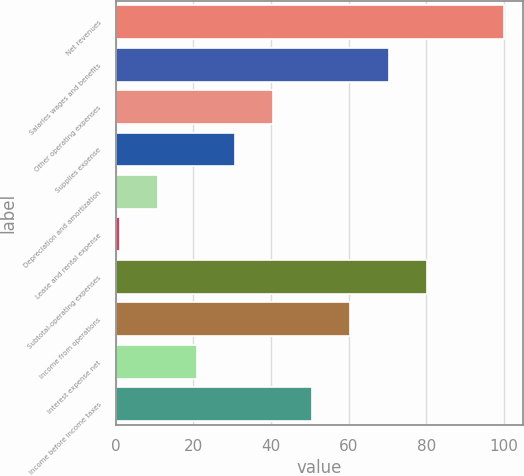Convert chart to OTSL. <chart><loc_0><loc_0><loc_500><loc_500><bar_chart><fcel>Net revenues<fcel>Salaries wages and benefits<fcel>Other operating expenses<fcel>Supplies expense<fcel>Depreciation and amortization<fcel>Lease and rental expense<fcel>Subtotal-operating expenses<fcel>Income from operations<fcel>Interest expense net<fcel>Income before income taxes<nl><fcel>100<fcel>70.33<fcel>40.66<fcel>30.77<fcel>10.99<fcel>1.1<fcel>80.22<fcel>60.44<fcel>20.88<fcel>50.55<nl></chart> 